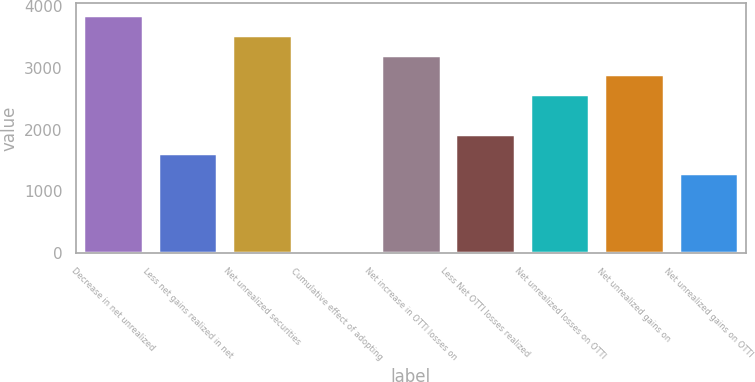Convert chart to OTSL. <chart><loc_0><loc_0><loc_500><loc_500><bar_chart><fcel>Decrease in net unrealized<fcel>Less net gains realized in net<fcel>Net unrealized securities<fcel>Cumulative effect of adopting<fcel>Net increase in OTTI losses on<fcel>Less Net OTTI losses realized<fcel>Net unrealized losses on OTTI<fcel>Net unrealized gains on<fcel>Net unrealized gains on OTTI<nl><fcel>3851.8<fcel>1612.5<fcel>3531.9<fcel>13<fcel>3212<fcel>1932.4<fcel>2572.2<fcel>2892.1<fcel>1292.6<nl></chart> 